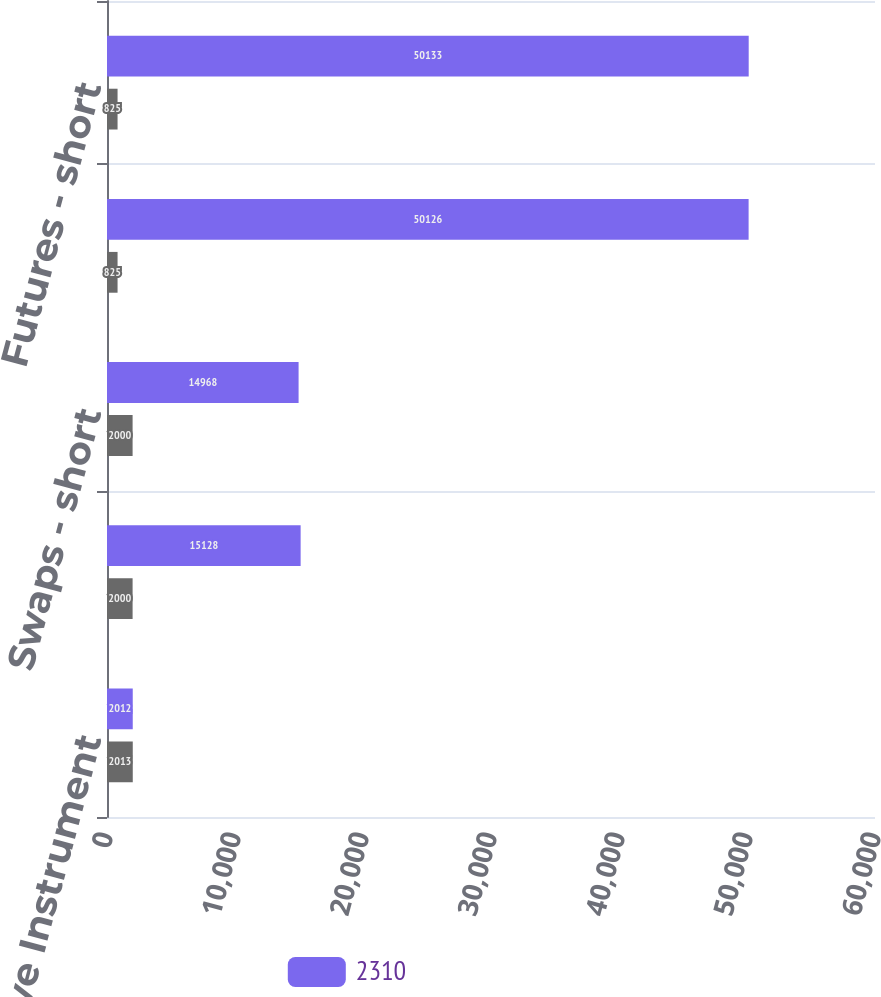Convert chart. <chart><loc_0><loc_0><loc_500><loc_500><stacked_bar_chart><ecel><fcel>Derivative Instrument<fcel>Swaps - long<fcel>Swaps - short<fcel>Futures - long<fcel>Futures - short<nl><fcel>2310<fcel>2012<fcel>15128<fcel>14968<fcel>50126<fcel>50133<nl><fcel>nan<fcel>2013<fcel>2000<fcel>2000<fcel>825<fcel>825<nl></chart> 